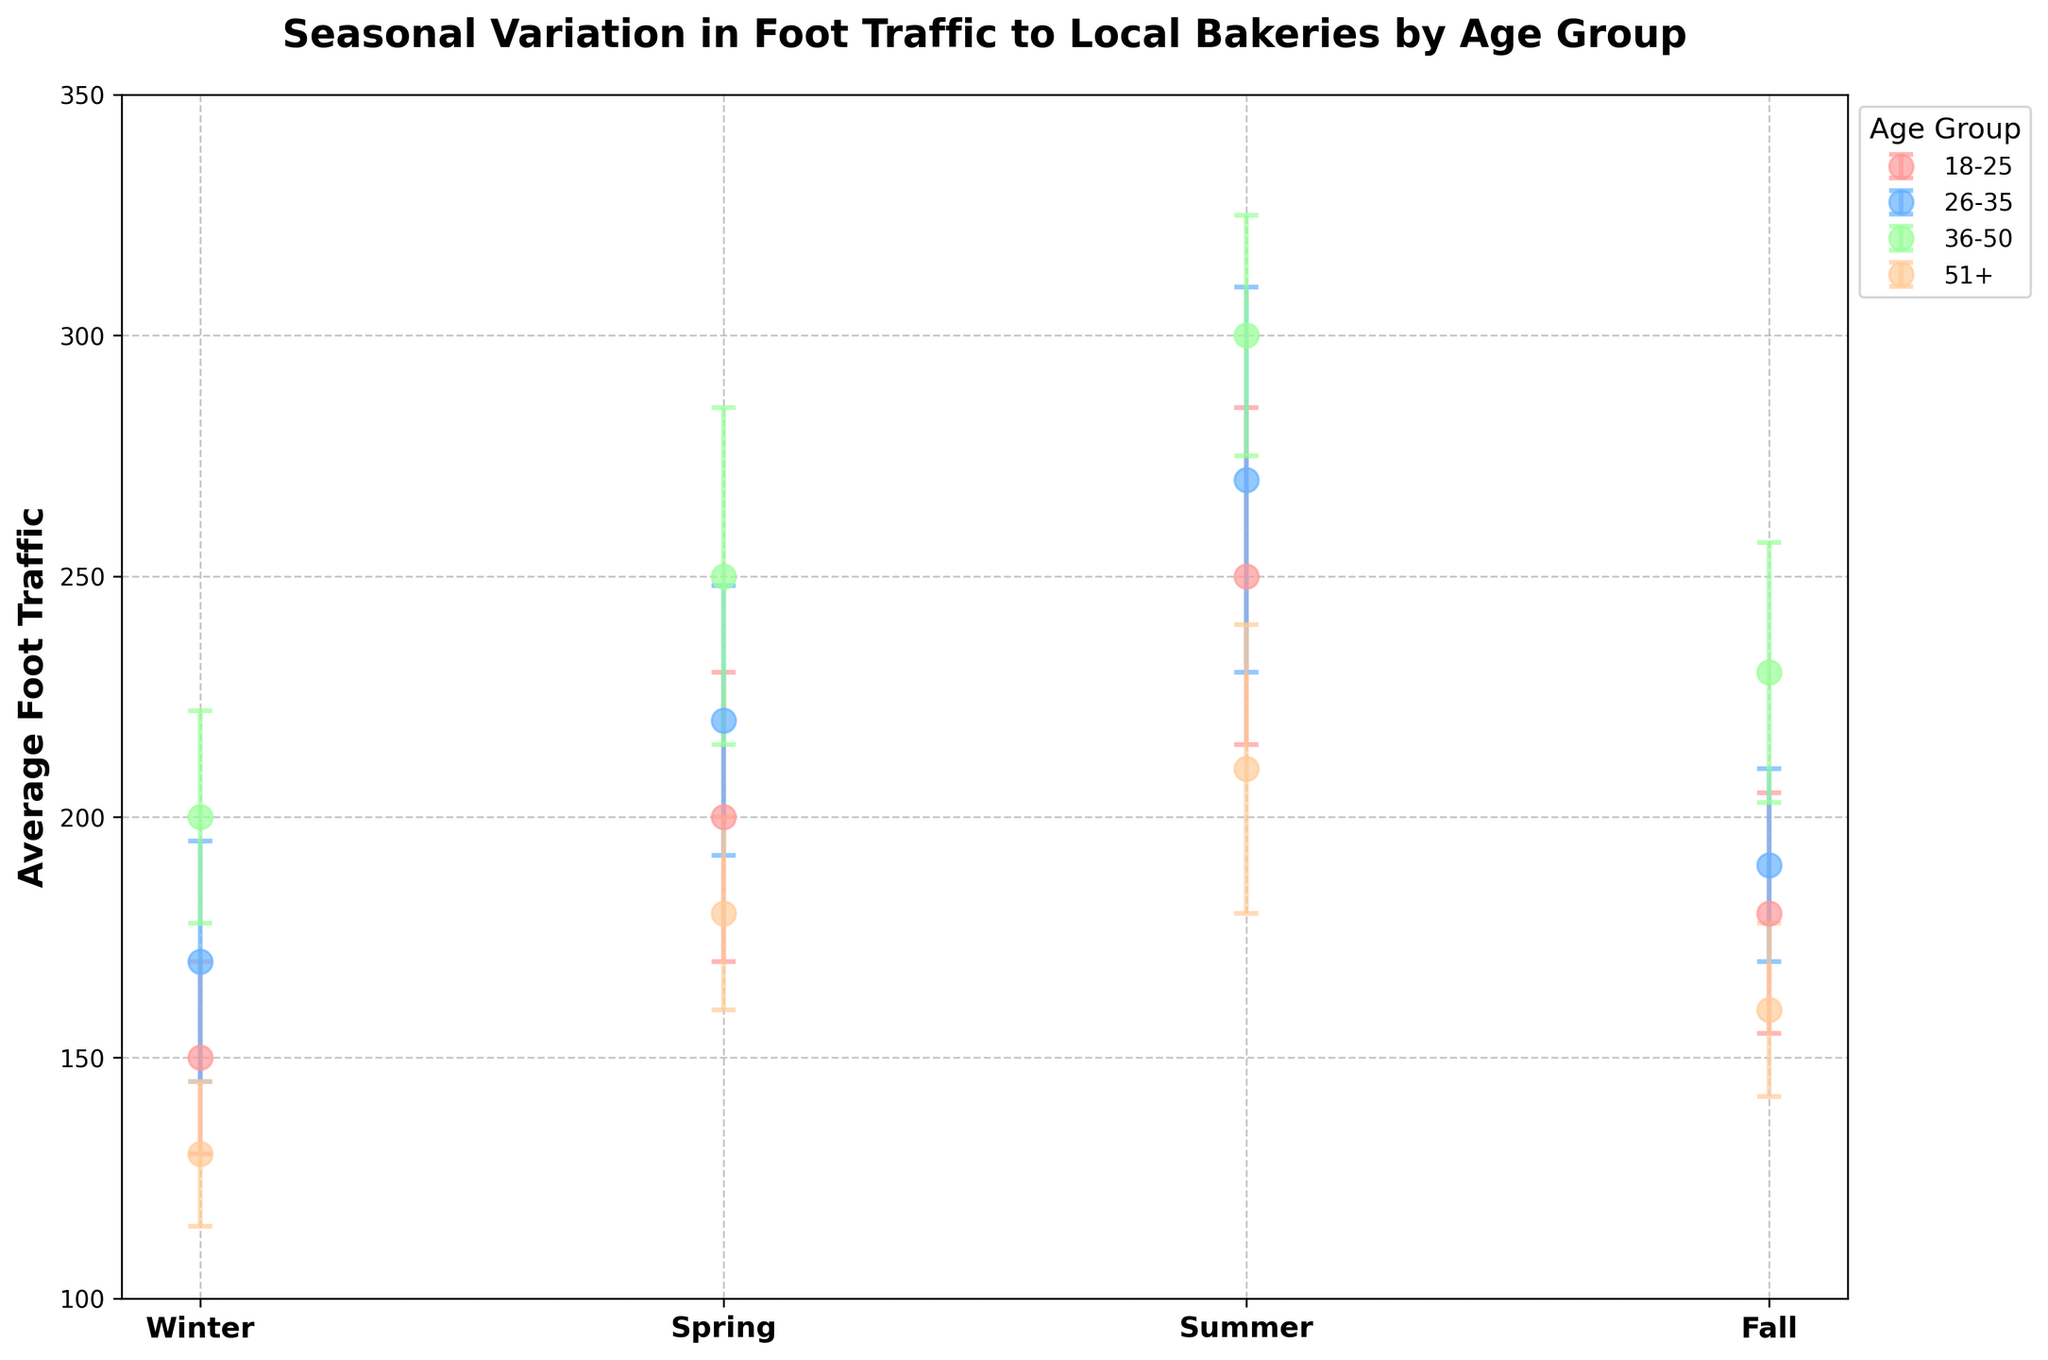What is the title of the figure? The title is usually located at the top of the figure and is often the largest text for quick visibility.
Answer: Seasonal Variation in Foot Traffic to Local Bakeries by Age Group Which season has the highest average foot traffic for the 18-25 age group? By observing the points linked with the 18-25 age group across all seasons, the highest value is in Summer.
Answer: Summer What is the average foot traffic for the 51+ age group in Winter? Locate the winter segment and find the data point for the 51+ age group; the value is 130.
Answer: 130 How does the average foot traffic for the 26-35 age group in Fall compare to that in Spring? From the plot, note the data points for the 26-35 age group in Fall and Spring and compare their values: Fall (190) vs. Spring (220).
Answer: Fall is lower What is the range (difference between maximum and minimum) of average foot traffic for the 36-50 age group across all seasons? Identify data points for 36-50 in all seasons (200 in Winter, 250 in Spring, 300 in Summer, 230 in Fall). Compute the range: 300 - 200 = 100.
Answer: 100 Which season and age group combination has the largest error bar? Identify the longest error bar across all data points. The 26-35 age group in Summer has the largest error bar (40).
Answer: 26-35 in Summer Are any age groups consistent in their average foot traffic across all seasons? Check if any age group's foot traffic data points are close in value across all seasons. No age group shows this consistency visibly.
Answer: No What is the trend of average foot traffic for the 18-25 age group from Winter to Summer? Observe the 18-25 data points sequentially from Winter to Summer: Winter (150), Spring (200), Summer (250). There is a consistent increase.
Answer: Increasing Does the 51+ age group ever have higher average foot traffic than the 18-25 group in any season? Compare each season's data for these two groups. Though their values are closer in some seasons, the 51+ group never surpasses the 18-25 group.
Answer: No Which season shows the widest range in average foot traffic between the youngest (18-25) and oldest (51+) age groups? Compute and compare the differences for each season. Summer has the widest range: 250 (18-25) - 210 (51+) = 40.
Answer: Summer 